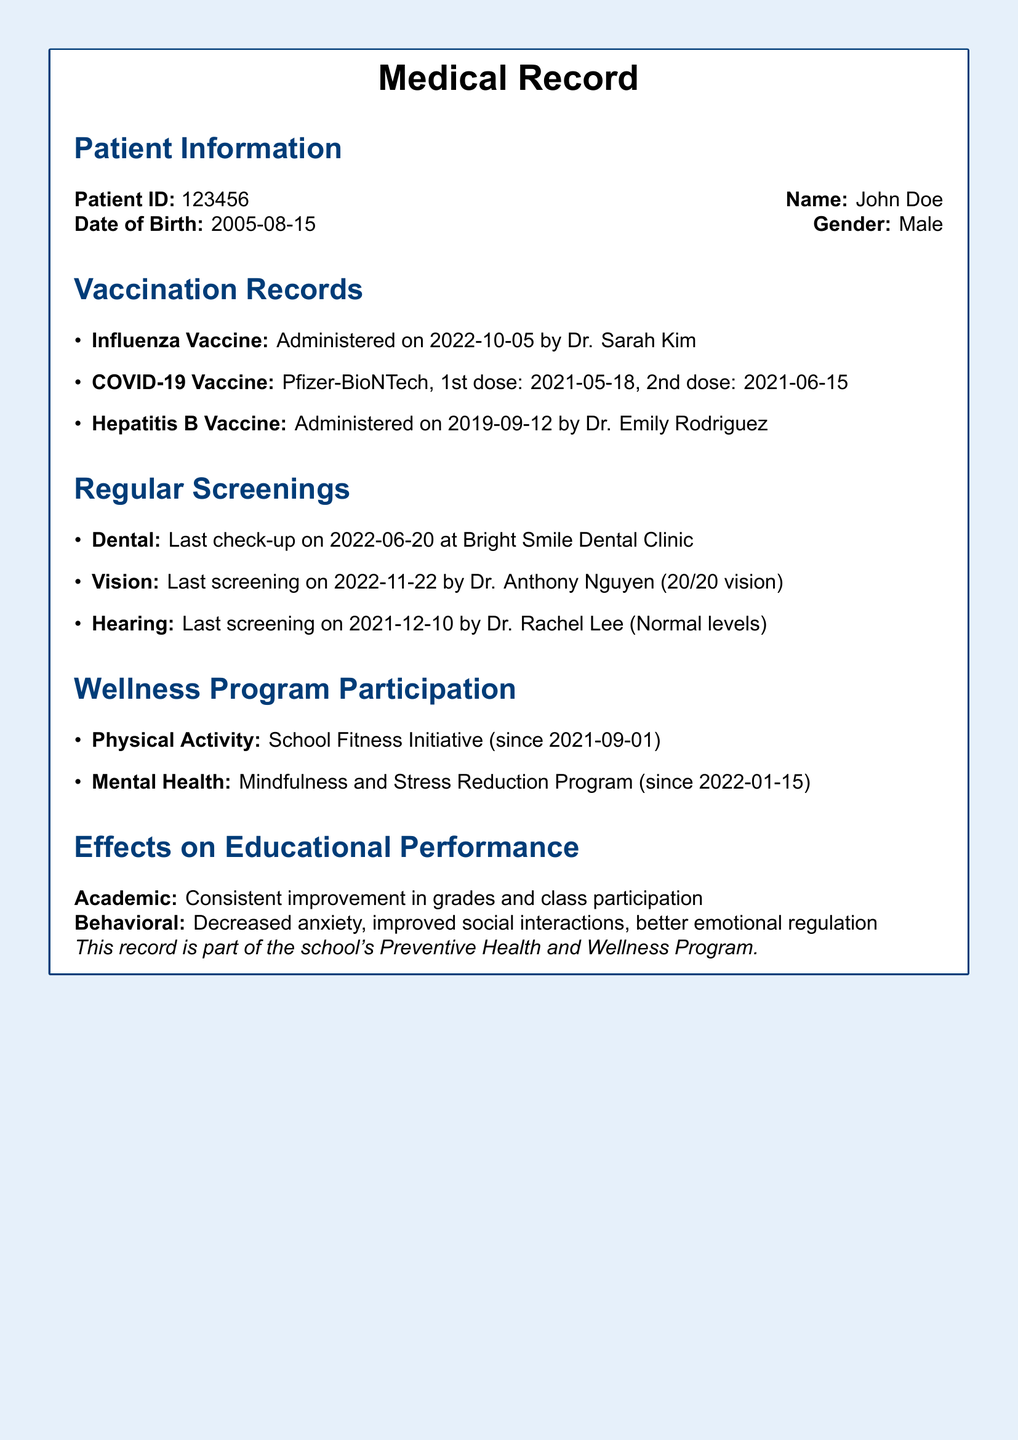What is the patient's name? The patient's name is explicitly stated in the document.
Answer: John Doe When was the last dental check-up? The date of the last dental check-up is provided under regular screenings.
Answer: 2022-06-20 What vaccine was administered on 2022-10-05? This date corresponds to a specific vaccination record in the document.
Answer: Influenza Vaccine Which program has been participated in since January 15, 2022? The dates and names of the wellness programs are listed in the document.
Answer: Mindfulness and Stress Reduction Program What is the patient's vision status? The information about the vision screening gives details on the patient's vision.
Answer: 20/20 vision What effect has been observed in class participation? The document describes observed effects on educational performance.
Answer: Consistent improvement How many doses of the COVID-19 vaccine were administered? The vaccination details mention the number of doses given.
Answer: 2 doses What type of wellness program is the School Fitness Initiative classified as? The wellness programs are categorized as physical activity or mental health.
Answer: Physical Activity 